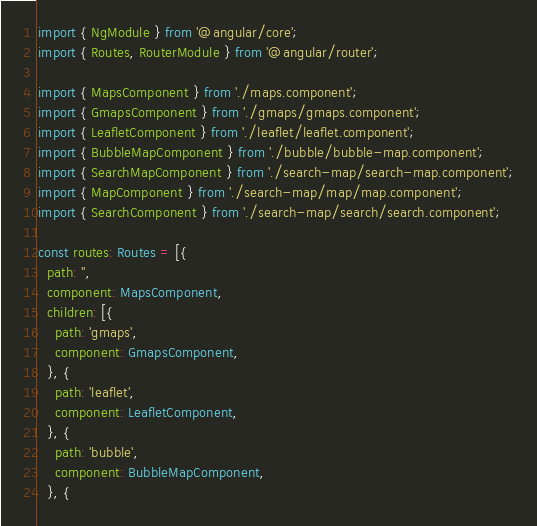<code> <loc_0><loc_0><loc_500><loc_500><_TypeScript_>import { NgModule } from '@angular/core';
import { Routes, RouterModule } from '@angular/router';

import { MapsComponent } from './maps.component';
import { GmapsComponent } from './gmaps/gmaps.component';
import { LeafletComponent } from './leaflet/leaflet.component';
import { BubbleMapComponent } from './bubble/bubble-map.component';
import { SearchMapComponent } from './search-map/search-map.component';
import { MapComponent } from './search-map/map/map.component';
import { SearchComponent } from './search-map/search/search.component';

const routes: Routes = [{
  path: '',
  component: MapsComponent,
  children: [{
    path: 'gmaps',
    component: GmapsComponent,
  }, {
    path: 'leaflet',
    component: LeafletComponent,
  }, {
    path: 'bubble',
    component: BubbleMapComponent,
  }, {</code> 